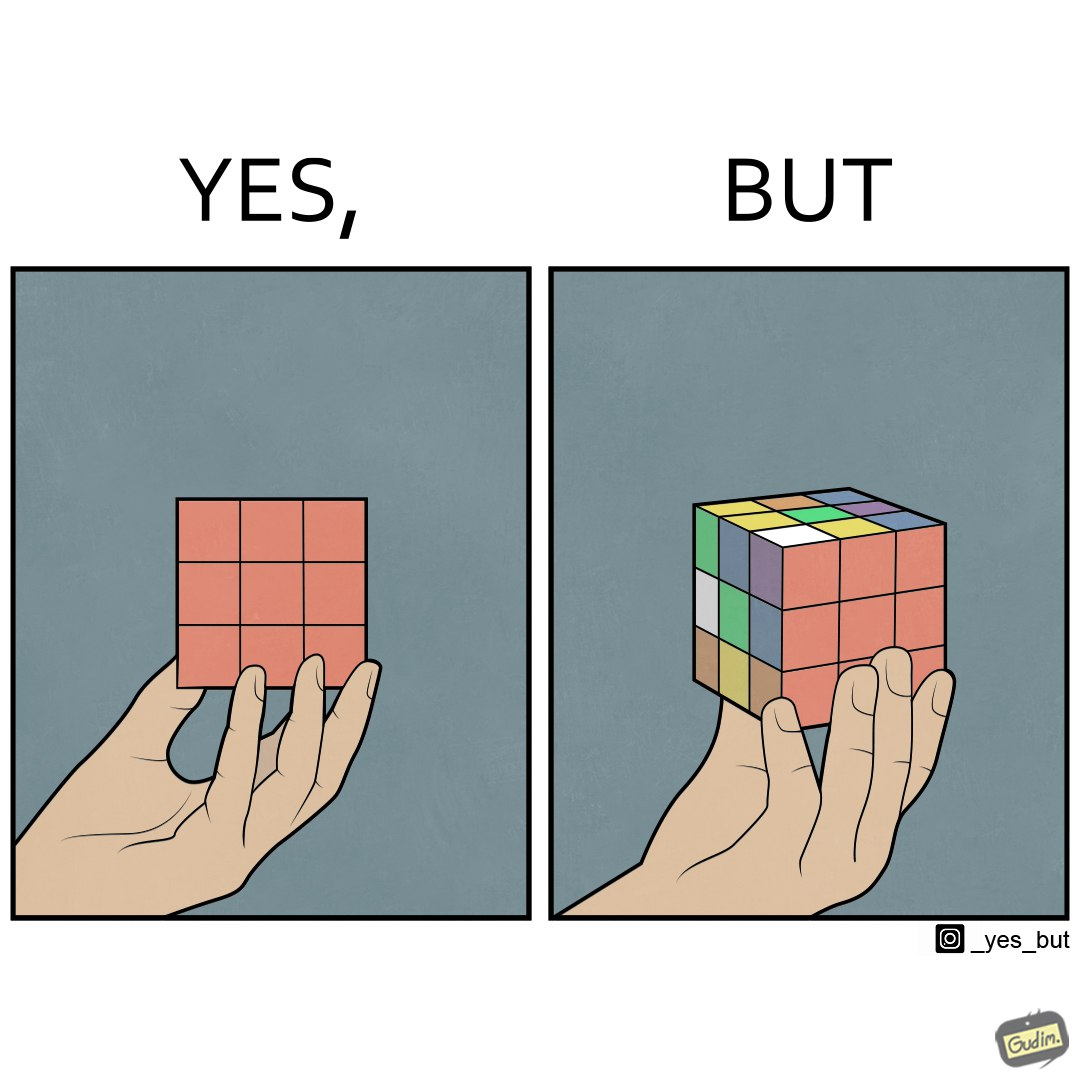Describe the content of this image. The images are funny since they show how a jumbled rubiks cube appears solved simply because of the viewers perspective. 